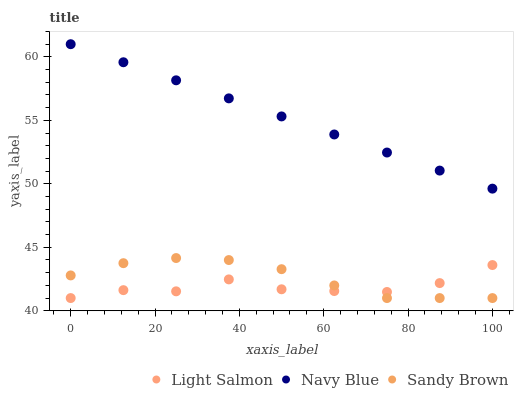Does Light Salmon have the minimum area under the curve?
Answer yes or no. Yes. Does Navy Blue have the maximum area under the curve?
Answer yes or no. Yes. Does Sandy Brown have the minimum area under the curve?
Answer yes or no. No. Does Sandy Brown have the maximum area under the curve?
Answer yes or no. No. Is Navy Blue the smoothest?
Answer yes or no. Yes. Is Light Salmon the roughest?
Answer yes or no. Yes. Is Sandy Brown the smoothest?
Answer yes or no. No. Is Sandy Brown the roughest?
Answer yes or no. No. Does Light Salmon have the lowest value?
Answer yes or no. Yes. Does Navy Blue have the highest value?
Answer yes or no. Yes. Does Sandy Brown have the highest value?
Answer yes or no. No. Is Sandy Brown less than Navy Blue?
Answer yes or no. Yes. Is Navy Blue greater than Sandy Brown?
Answer yes or no. Yes. Does Sandy Brown intersect Light Salmon?
Answer yes or no. Yes. Is Sandy Brown less than Light Salmon?
Answer yes or no. No. Is Sandy Brown greater than Light Salmon?
Answer yes or no. No. Does Sandy Brown intersect Navy Blue?
Answer yes or no. No. 